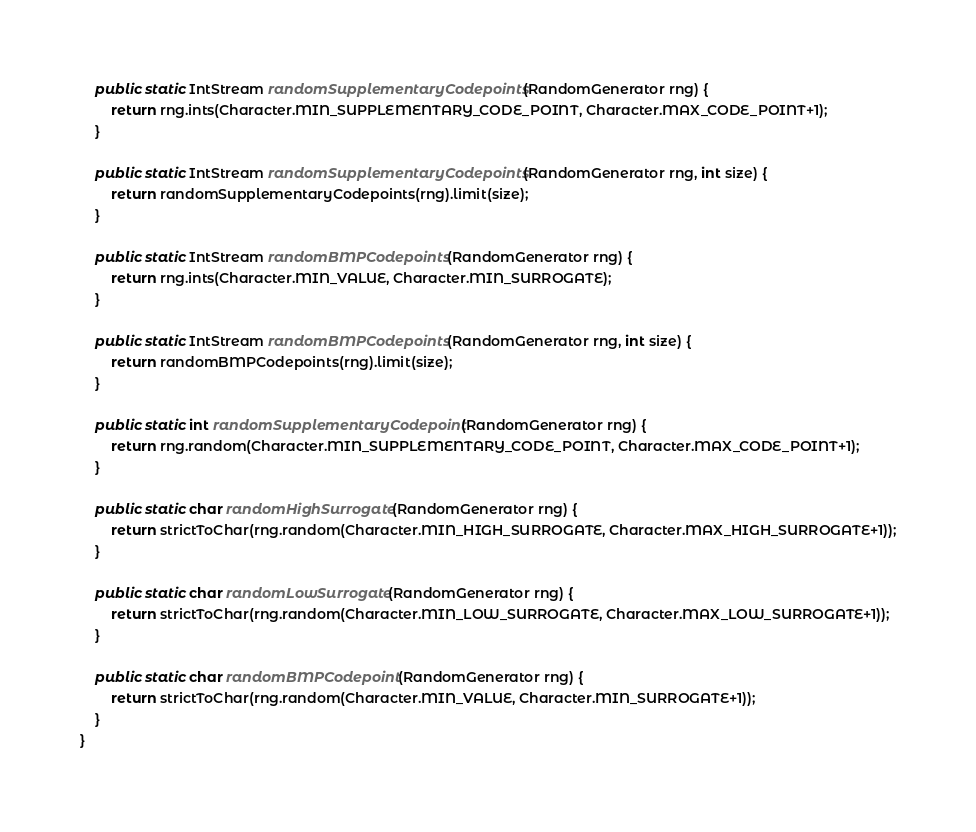Convert code to text. <code><loc_0><loc_0><loc_500><loc_500><_Java_>	public static IntStream randomSupplementaryCodepoints(RandomGenerator rng) {
		return rng.ints(Character.MIN_SUPPLEMENTARY_CODE_POINT, Character.MAX_CODE_POINT+1);
	}

	public static IntStream randomSupplementaryCodepoints(RandomGenerator rng, int size) {
		return randomSupplementaryCodepoints(rng).limit(size);
	}

	public static IntStream randomBMPCodepoints(RandomGenerator rng) {
		return rng.ints(Character.MIN_VALUE, Character.MIN_SURROGATE);
	}

	public static IntStream randomBMPCodepoints(RandomGenerator rng, int size) {
		return randomBMPCodepoints(rng).limit(size);
	}

	public static int randomSupplementaryCodepoint(RandomGenerator rng) {
		return rng.random(Character.MIN_SUPPLEMENTARY_CODE_POINT, Character.MAX_CODE_POINT+1);
	}

	public static char randomHighSurrogate(RandomGenerator rng) {
		return strictToChar(rng.random(Character.MIN_HIGH_SURROGATE, Character.MAX_HIGH_SURROGATE+1));
	}

	public static char randomLowSurrogate(RandomGenerator rng) {
		return strictToChar(rng.random(Character.MIN_LOW_SURROGATE, Character.MAX_LOW_SURROGATE+1));
	}

	public static char randomBMPCodepoint(RandomGenerator rng) {
		return strictToChar(rng.random(Character.MIN_VALUE, Character.MIN_SURROGATE+1));
	}
}
</code> 